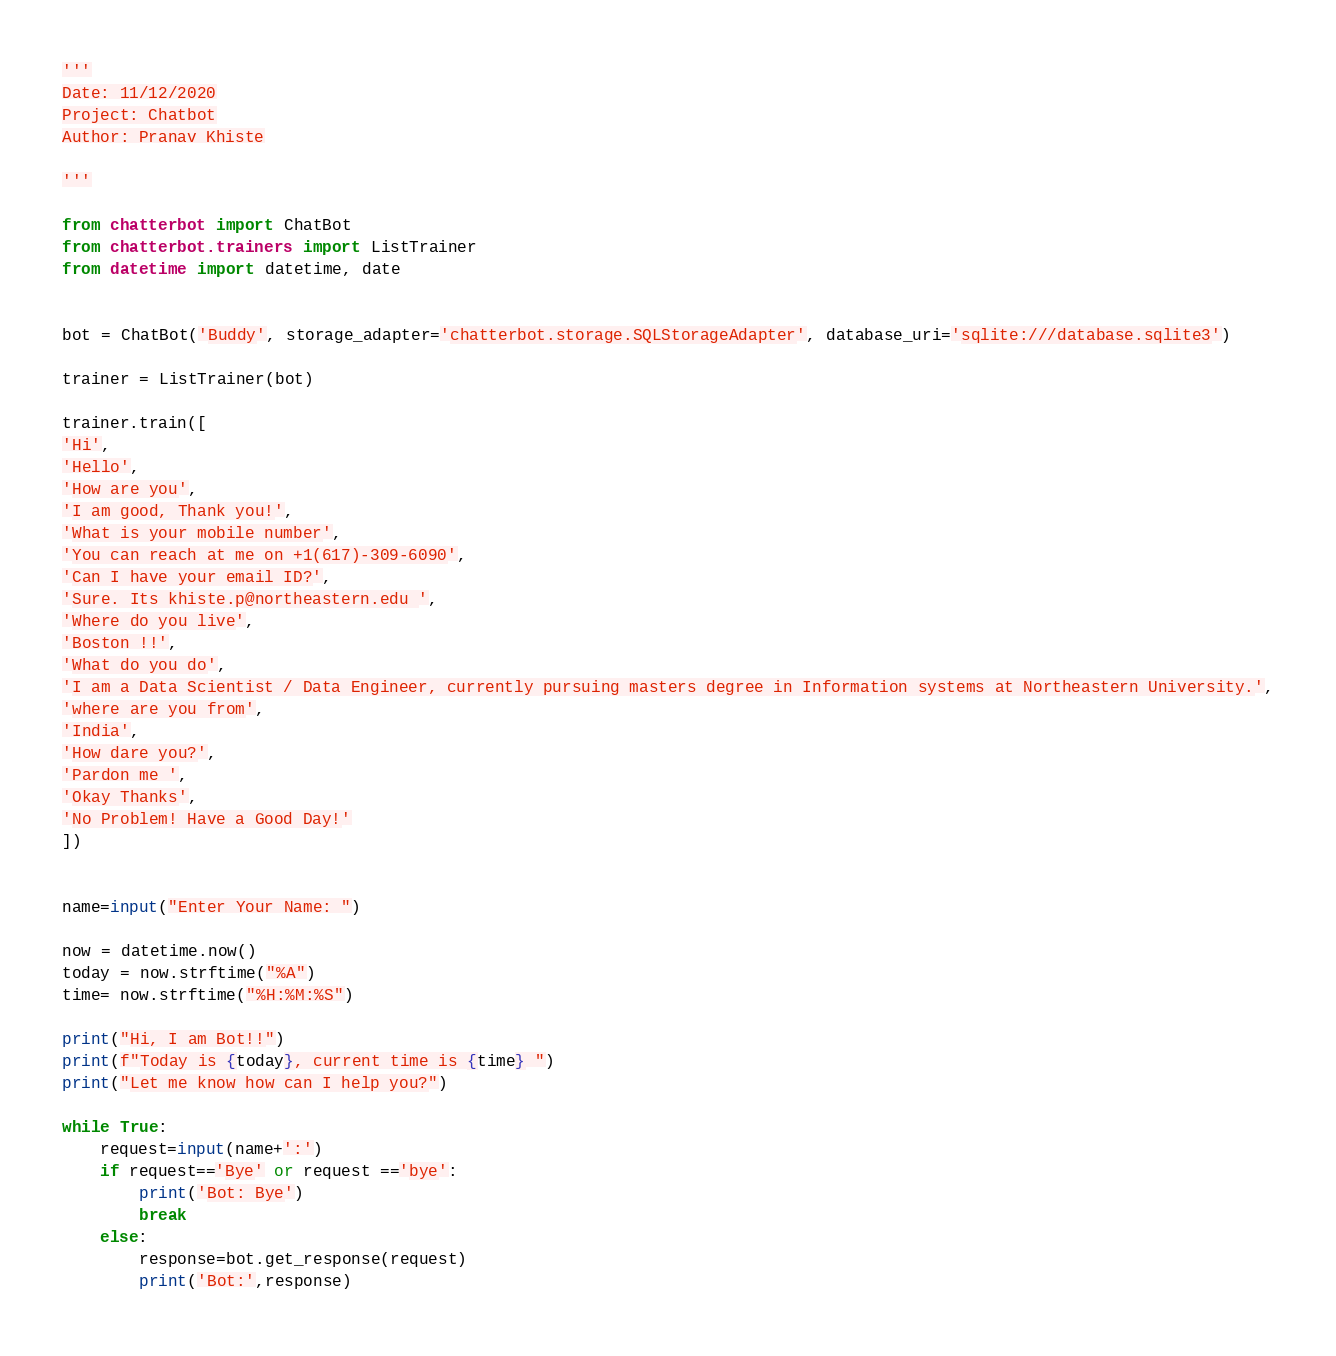Convert code to text. <code><loc_0><loc_0><loc_500><loc_500><_Python_>'''
Date: 11/12/2020
Project: Chatbot
Author: Pranav Khiste

'''

from chatterbot import ChatBot
from chatterbot.trainers import ListTrainer
from datetime import datetime, date


bot = ChatBot('Buddy', storage_adapter='chatterbot.storage.SQLStorageAdapter', database_uri='sqlite:///database.sqlite3')

trainer = ListTrainer(bot)

trainer.train([
'Hi',
'Hello',
'How are you',
'I am good, Thank you!',
'What is your mobile number',
'You can reach at me on +1(617)-309-6090',
'Can I have your email ID?',
'Sure. Its khiste.p@northeastern.edu ',
'Where do you live',
'Boston !!',
'What do you do',
'I am a Data Scientist / Data Engineer, currently pursuing masters degree in Information systems at Northeastern University.',
'where are you from',
'India',
'How dare you?',
'Pardon me ',
'Okay Thanks',
'No Problem! Have a Good Day!'
])


name=input("Enter Your Name: ")

now = datetime.now()
today = now.strftime("%A")
time= now.strftime("%H:%M:%S")

print("Hi, I am Bot!!")
print(f"Today is {today}, current time is {time} ")
print("Let me know how can I help you?")

while True:
    request=input(name+':')
    if request=='Bye' or request =='bye':
        print('Bot: Bye')
        break
    else:
        response=bot.get_response(request)
        print('Bot:',response)</code> 